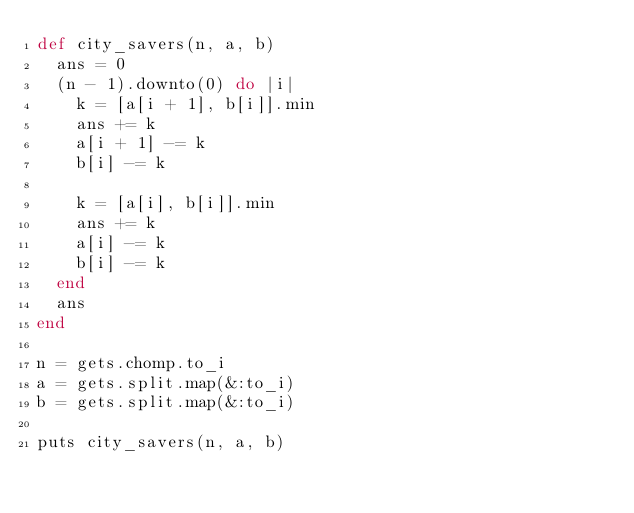<code> <loc_0><loc_0><loc_500><loc_500><_Ruby_>def city_savers(n, a, b)
  ans = 0
  (n - 1).downto(0) do |i|
    k = [a[i + 1], b[i]].min
    ans += k
    a[i + 1] -= k
    b[i] -= k

    k = [a[i], b[i]].min
    ans += k
    a[i] -= k
    b[i] -= k
  end
  ans
end

n = gets.chomp.to_i
a = gets.split.map(&:to_i)
b = gets.split.map(&:to_i)

puts city_savers(n, a, b)
</code> 